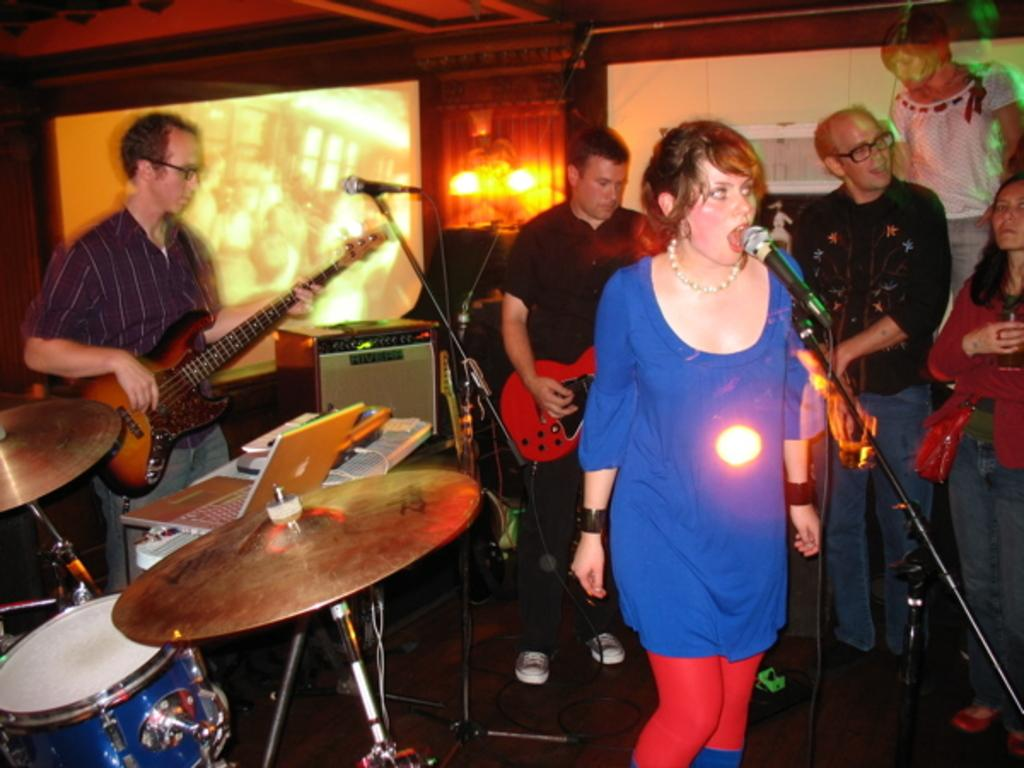What is the woman in the image doing? The woman is singing in the image. What is the woman holding while singing? The woman is holding a microphone. What instrument is being played by another person in the image? There is a person playing the guitar in the image. Can you describe the presence of other people in the image? There are people in the background of the image. What type of government is depicted in the image? There is no depiction of a government in the image; it features a woman singing and a person playing the guitar. Can you describe the ray of light shining on the guitar in the image? There is no ray of light shining on the guitar in the image; the lighting is not described in the provided facts. 